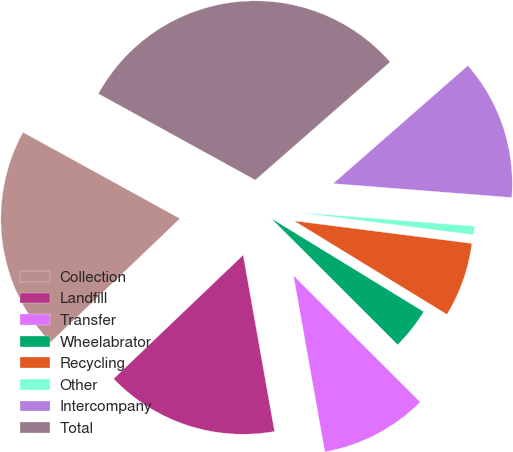Convert chart to OTSL. <chart><loc_0><loc_0><loc_500><loc_500><pie_chart><fcel>Collection<fcel>Landfill<fcel>Transfer<fcel>Wheelabrator<fcel>Recycling<fcel>Other<fcel>Intercompany<fcel>Total<nl><fcel>20.14%<fcel>15.67%<fcel>9.71%<fcel>3.75%<fcel>6.73%<fcel>0.77%<fcel>12.69%<fcel>30.56%<nl></chart> 